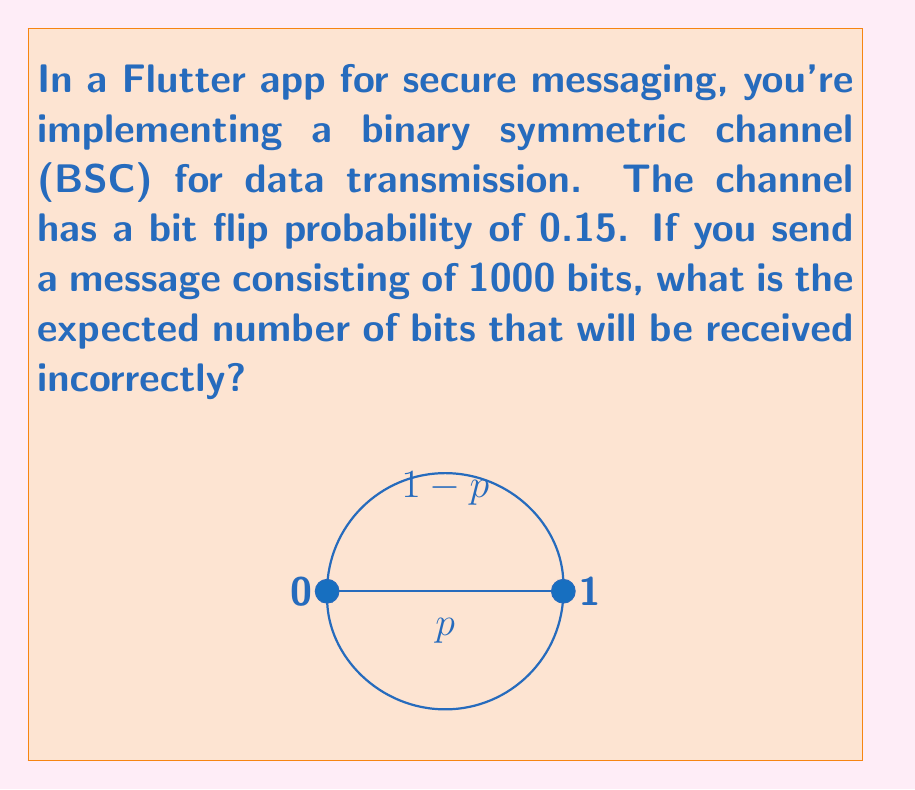Teach me how to tackle this problem. Let's approach this step-by-step:

1) In a binary symmetric channel, each bit has a probability $p$ of being flipped (0 to 1 or 1 to 0). In this case, $p = 0.15$.

2) For each bit transmitted, the probability of it being received incorrectly is equal to the bit flip probability, $p$.

3) The number of incorrectly received bits in a message follows a binomial distribution, where:
   - $n$ is the number of bits in the message (1000 in this case)
   - $p$ is the probability of a bit being flipped (0.15)

4) The expected value (mean) of a binomial distribution is given by:

   $$E(X) = np$$

   Where $X$ is the random variable representing the number of incorrect bits.

5) Substituting our values:

   $$E(X) = 1000 \times 0.15 = 150$$

Therefore, the expected number of incorrectly received bits is 150.
Answer: 150 bits 